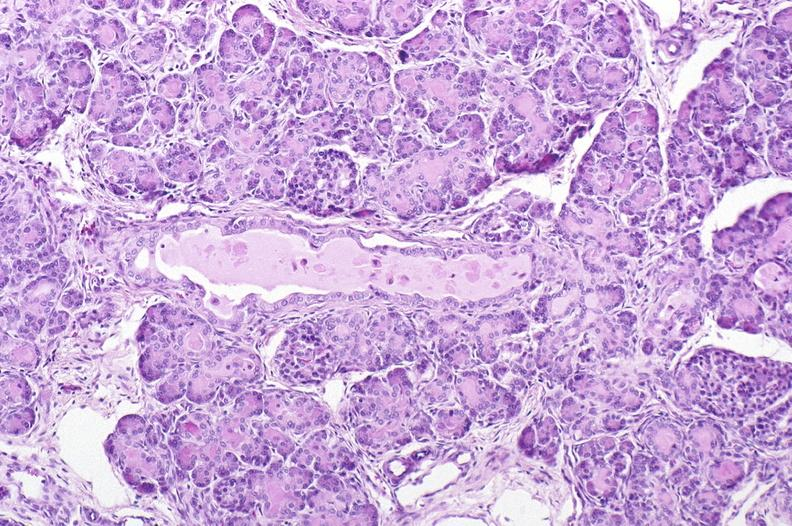does this image show cystic fibrosis?
Answer the question using a single word or phrase. Yes 